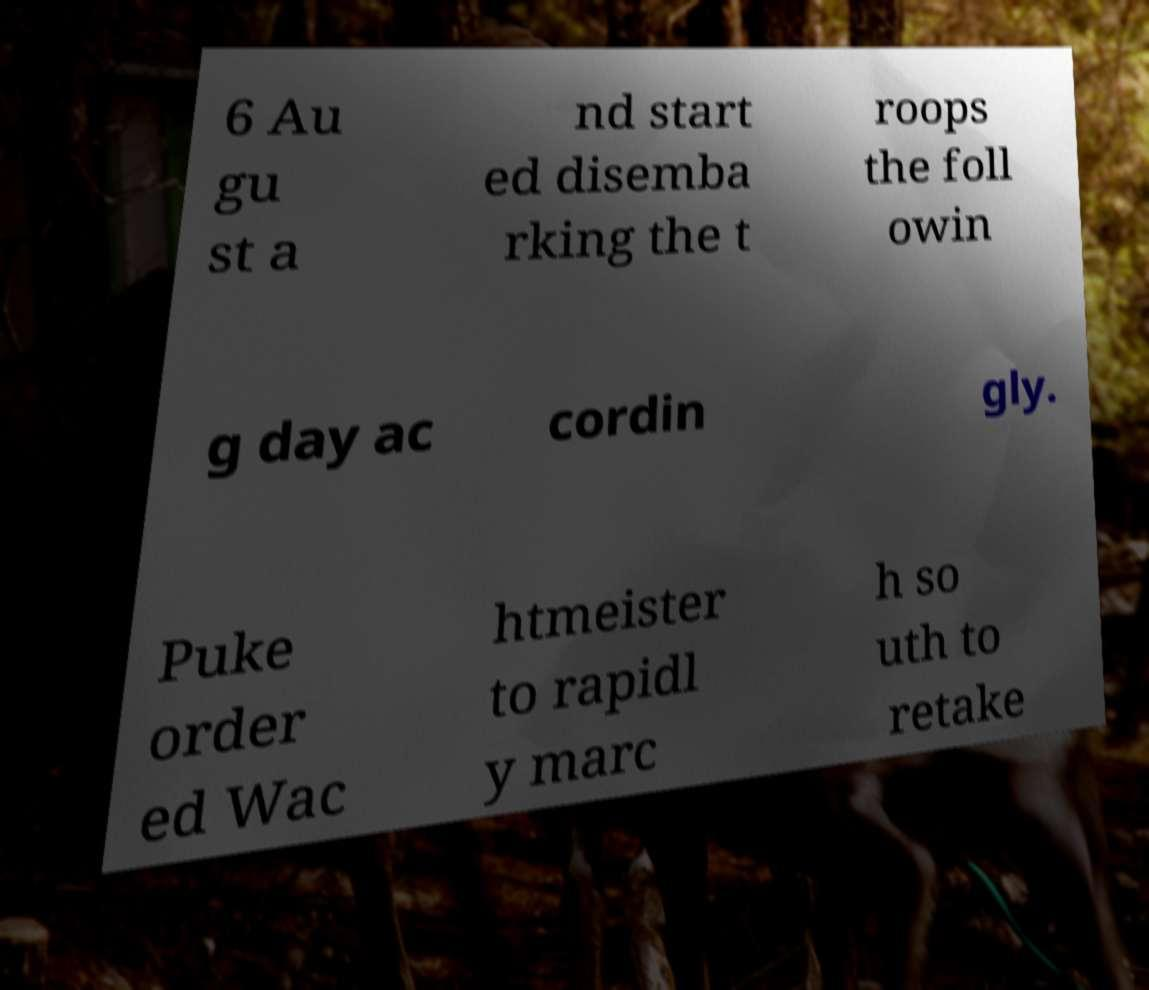For documentation purposes, I need the text within this image transcribed. Could you provide that? 6 Au gu st a nd start ed disemba rking the t roops the foll owin g day ac cordin gly. Puke order ed Wac htmeister to rapidl y marc h so uth to retake 